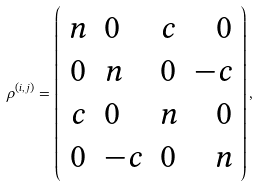Convert formula to latex. <formula><loc_0><loc_0><loc_500><loc_500>\rho ^ { ( i , j ) } = \left ( { \begin{array} { c l c r } n & 0 & c & 0 \\ 0 & n & 0 & - c \\ c & 0 & n & 0 \\ 0 & - c & 0 & n \end{array} } \right ) ,</formula> 